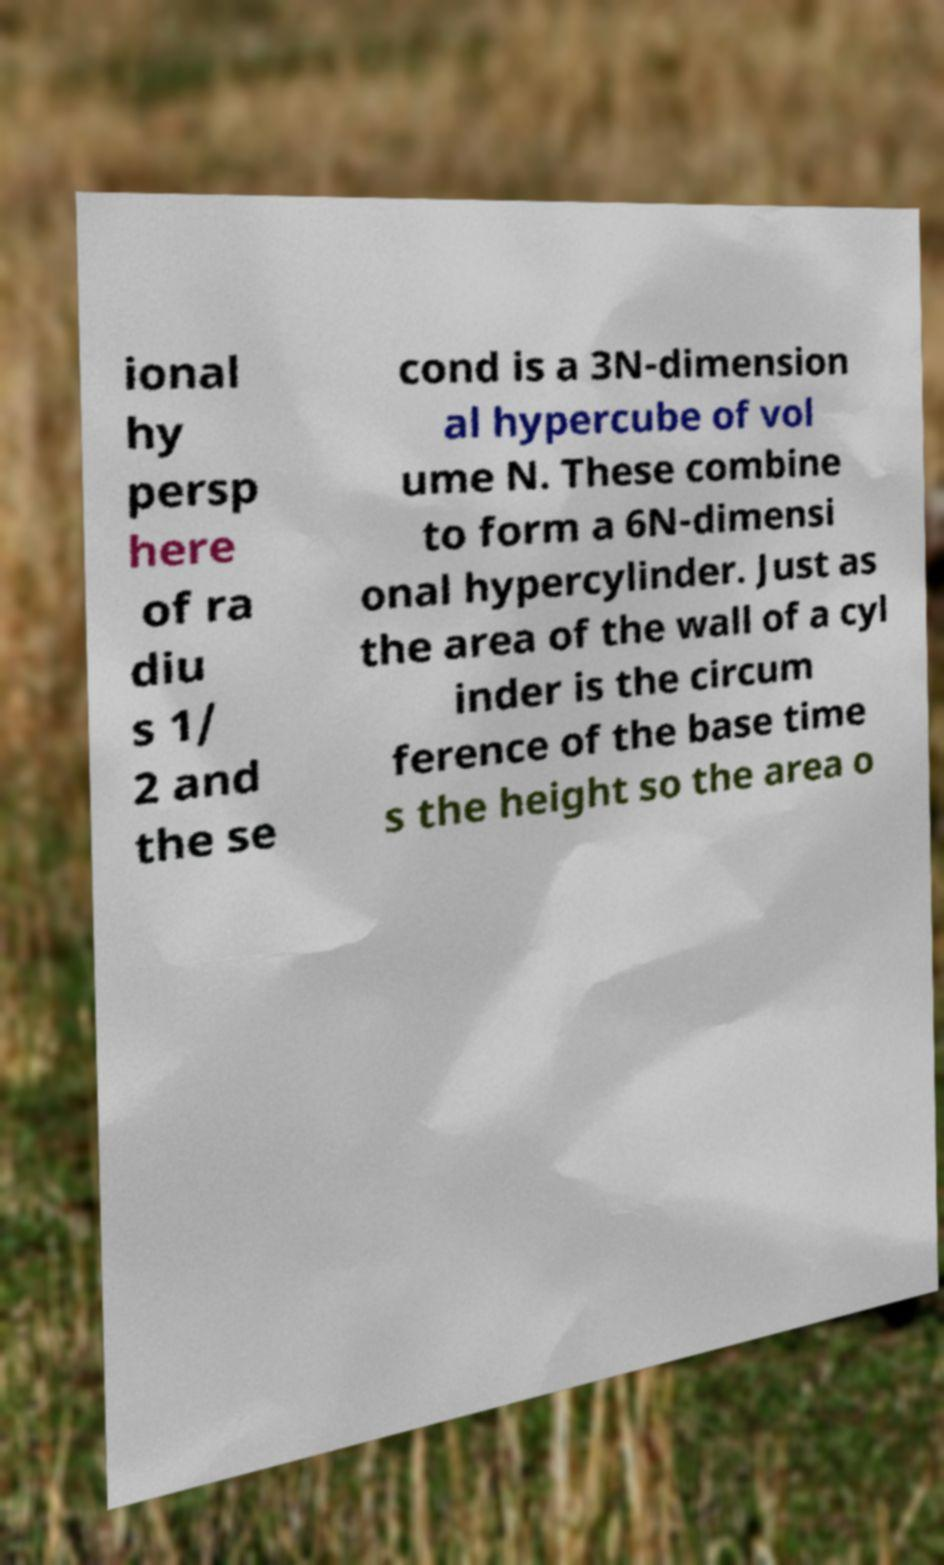What messages or text are displayed in this image? I need them in a readable, typed format. ional hy persp here of ra diu s 1/ 2 and the se cond is a 3N-dimension al hypercube of vol ume N. These combine to form a 6N-dimensi onal hypercylinder. Just as the area of the wall of a cyl inder is the circum ference of the base time s the height so the area o 